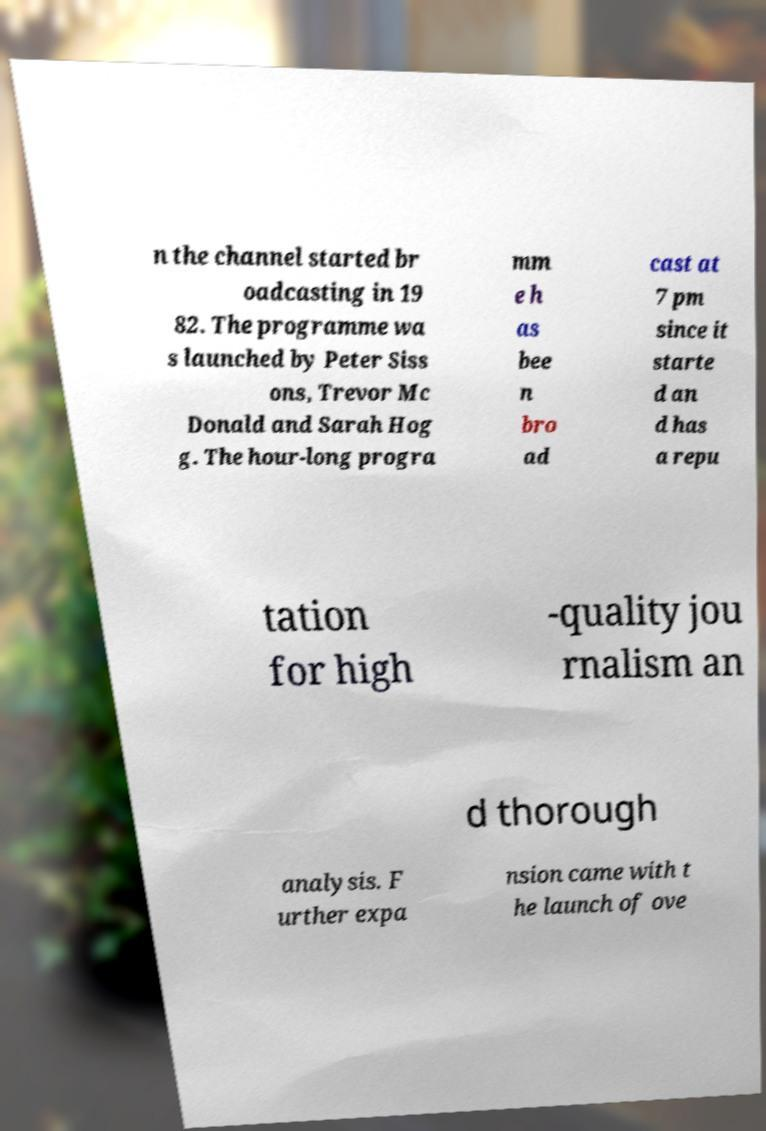Could you assist in decoding the text presented in this image and type it out clearly? n the channel started br oadcasting in 19 82. The programme wa s launched by Peter Siss ons, Trevor Mc Donald and Sarah Hog g. The hour-long progra mm e h as bee n bro ad cast at 7 pm since it starte d an d has a repu tation for high -quality jou rnalism an d thorough analysis. F urther expa nsion came with t he launch of ove 